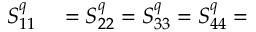Convert formula to latex. <formula><loc_0><loc_0><loc_500><loc_500>\begin{array} { r l } { S _ { 1 1 } ^ { q } } & = S _ { 2 2 } ^ { q } = S _ { 3 3 } ^ { q } = S _ { 4 4 } ^ { q } = } \end{array}</formula> 